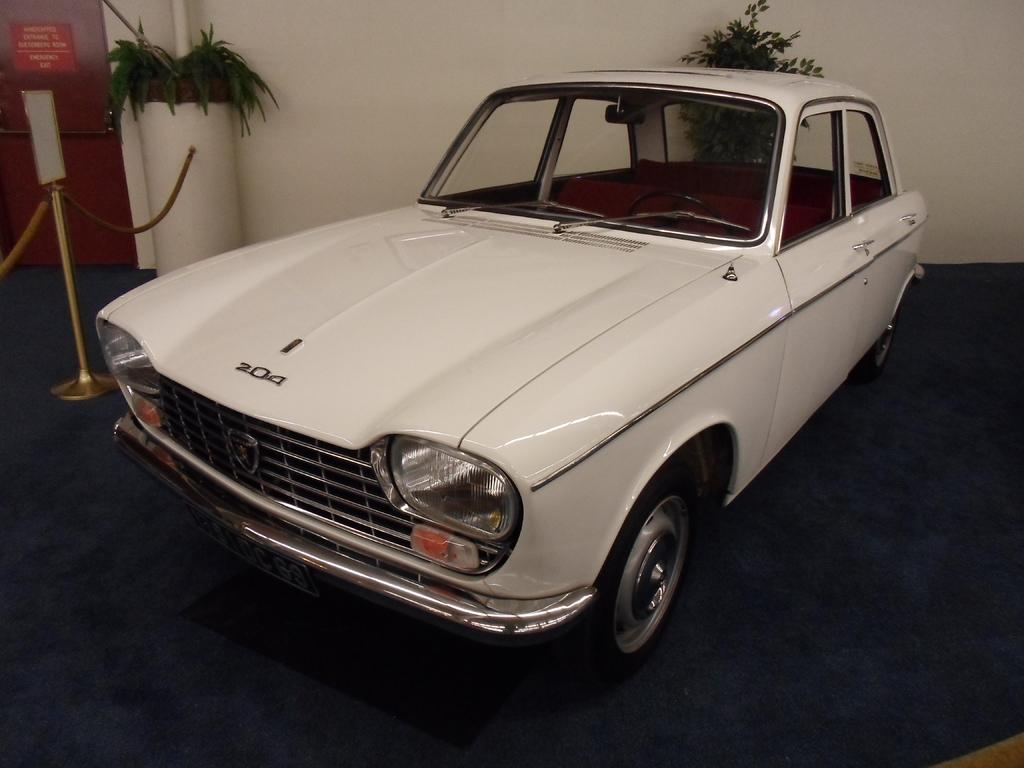What is the color of the wall in the image? The wall in the image is white. What can be seen parked near the wall? There is a car in the image. What feature is present on the wall? There is a door in the image. What type of vegetation is visible in the image? There are plants in the image. Where is the quilt hanging in the image? There is no quilt present in the image. What type of blade can be seen cutting through the plants in the image? There are no blades or cutting actions depicted in the image; it only shows plants. 